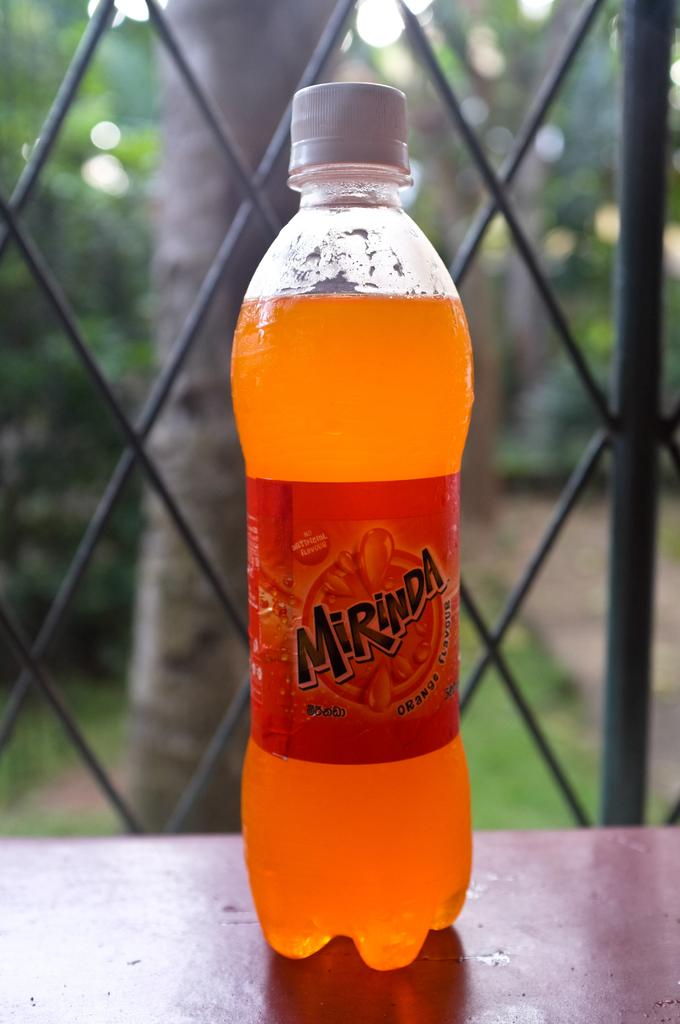What object is present on the table in the image? There is a bottle on the table in the image. What can be seen in the background of the image? There is a tree and grass visible in the background of the image. What type of linen is draped over the tree in the image? There is no linen present in the image, and the tree is not draped with any fabric. 